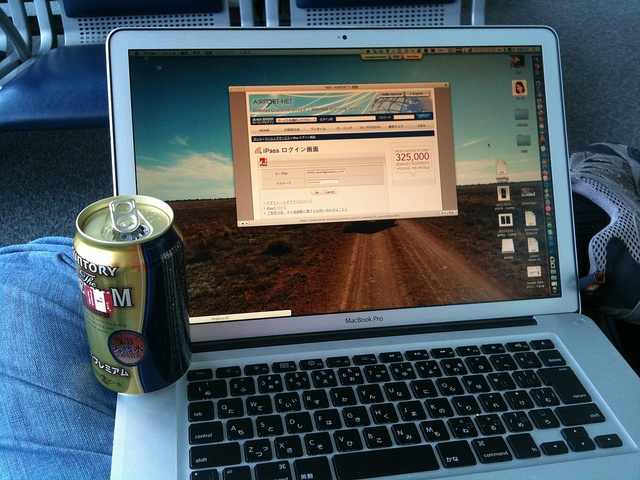Describe the objects in this image and their specific colors. I can see laptop in black, gray, and tan tones, people in black, lightblue, blue, and gray tones, chair in black, navy, darkblue, and gray tones, chair in black, gray, blue, and navy tones, and chair in black, navy, gray, blue, and darkblue tones in this image. 